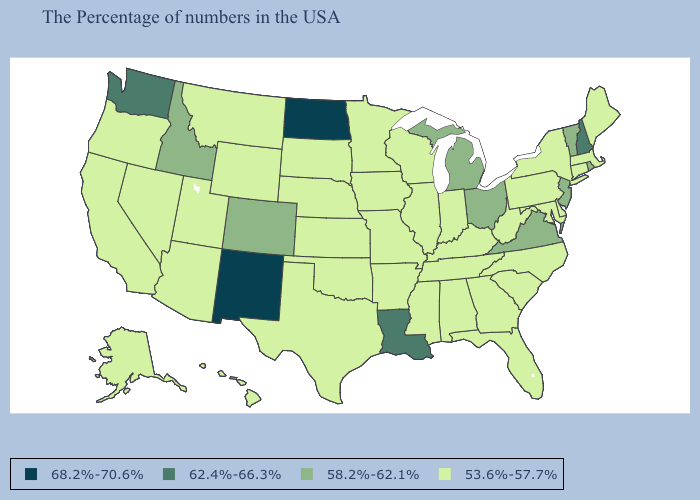What is the lowest value in states that border Arkansas?
Quick response, please. 53.6%-57.7%. What is the lowest value in states that border Idaho?
Quick response, please. 53.6%-57.7%. What is the lowest value in the MidWest?
Keep it brief. 53.6%-57.7%. Which states hav the highest value in the MidWest?
Concise answer only. North Dakota. Name the states that have a value in the range 62.4%-66.3%?
Write a very short answer. New Hampshire, Louisiana, Washington. What is the highest value in states that border Arizona?
Answer briefly. 68.2%-70.6%. Does the map have missing data?
Quick response, please. No. Does the map have missing data?
Give a very brief answer. No. Name the states that have a value in the range 62.4%-66.3%?
Keep it brief. New Hampshire, Louisiana, Washington. What is the value of Texas?
Concise answer only. 53.6%-57.7%. Does Louisiana have the highest value in the South?
Be succinct. Yes. Name the states that have a value in the range 68.2%-70.6%?
Quick response, please. North Dakota, New Mexico. Name the states that have a value in the range 62.4%-66.3%?
Give a very brief answer. New Hampshire, Louisiana, Washington. Name the states that have a value in the range 53.6%-57.7%?
Concise answer only. Maine, Massachusetts, Connecticut, New York, Delaware, Maryland, Pennsylvania, North Carolina, South Carolina, West Virginia, Florida, Georgia, Kentucky, Indiana, Alabama, Tennessee, Wisconsin, Illinois, Mississippi, Missouri, Arkansas, Minnesota, Iowa, Kansas, Nebraska, Oklahoma, Texas, South Dakota, Wyoming, Utah, Montana, Arizona, Nevada, California, Oregon, Alaska, Hawaii. Does Idaho have the lowest value in the USA?
Quick response, please. No. 